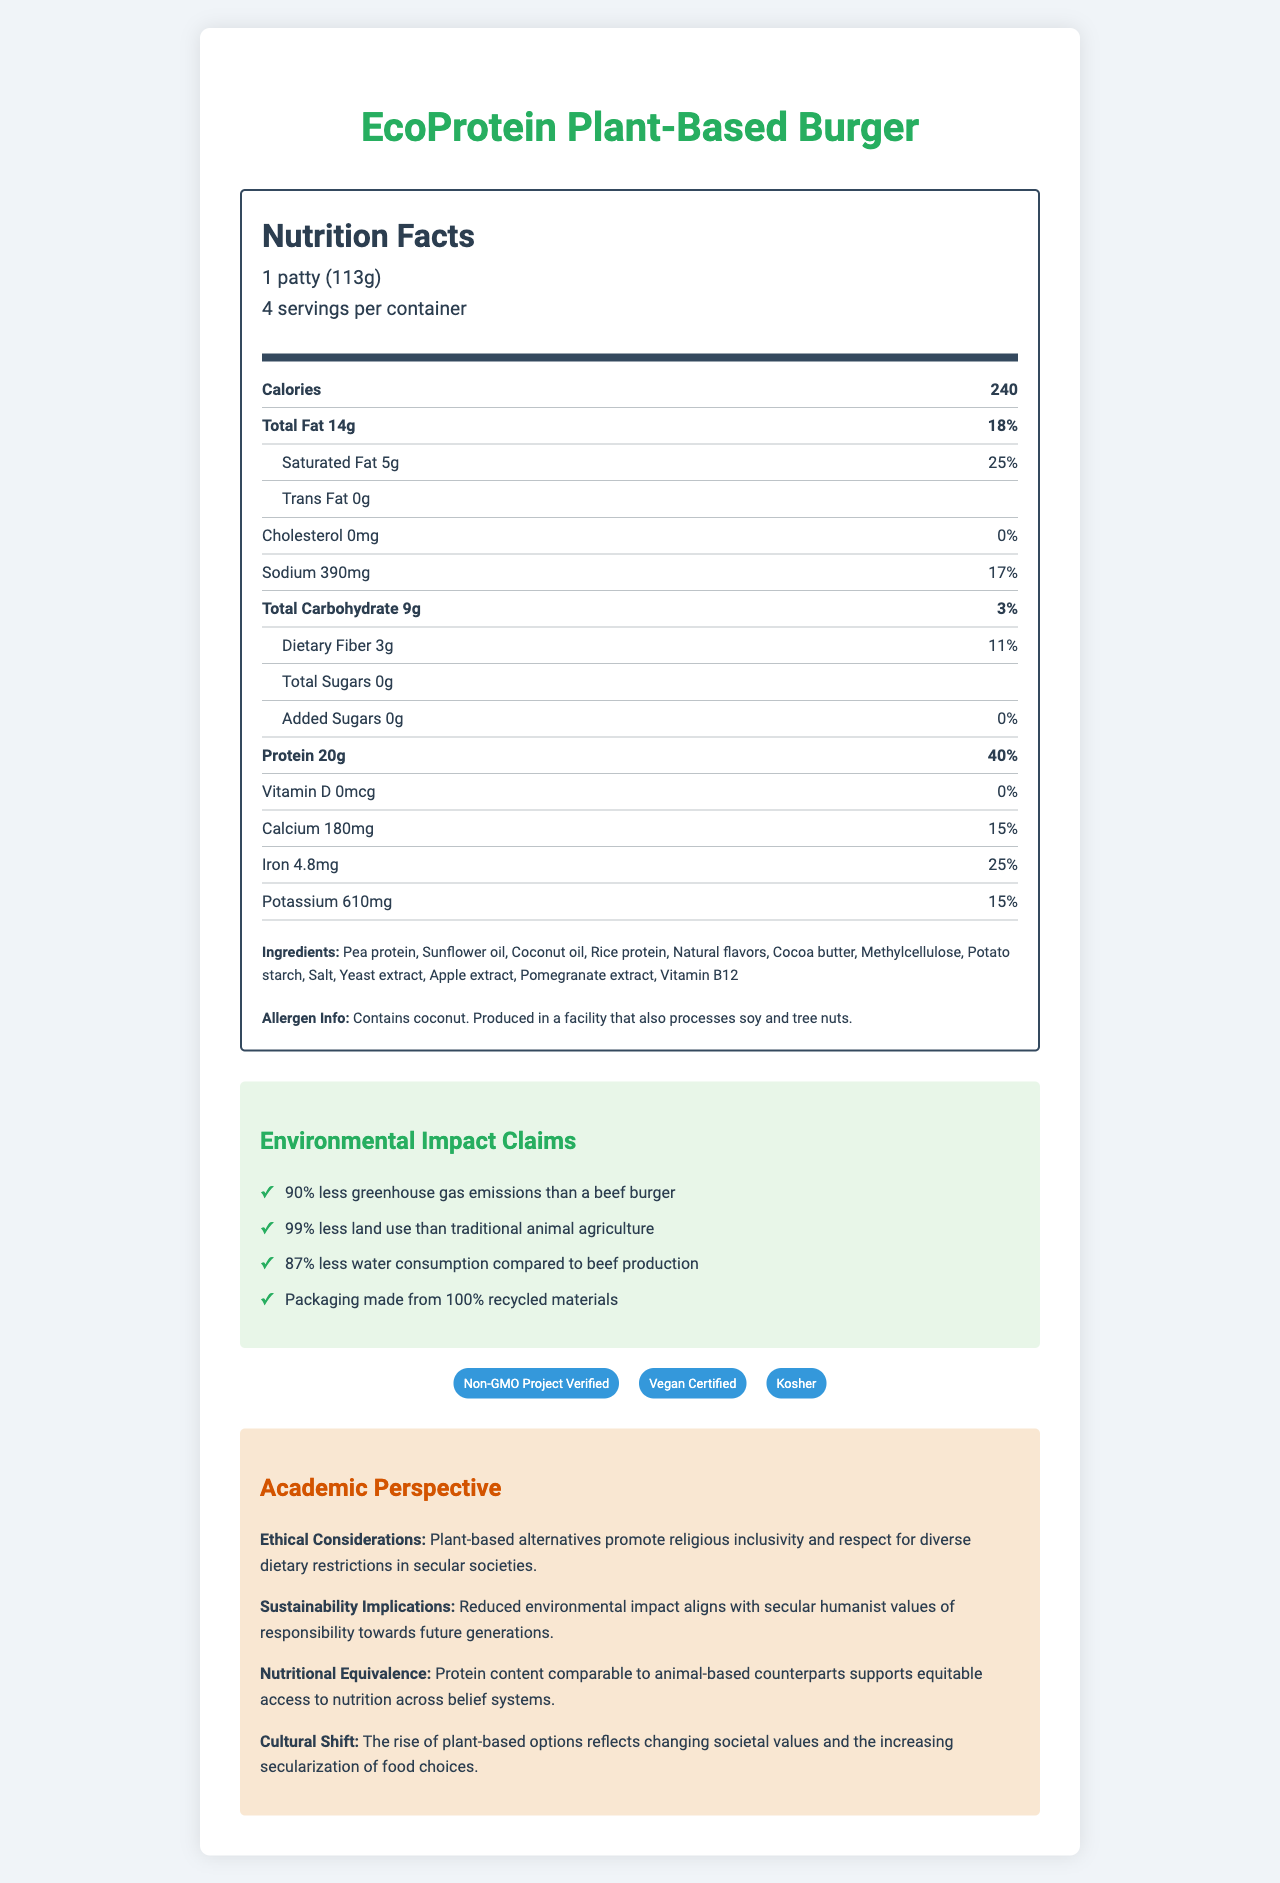how many servings are in one container? The document states there are 4 servings per container.
Answer: 4 What is the serving size of the EcoProtein Plant-Based Burger? The document lists the serving size as "1 patty (113g)."
Answer: 1 patty (113g) How many grams of protein are in one serving? The nutrition facts section states there are 20g of protein per serving.
Answer: 20g What percent of the daily value does the protein content represent? The document indicates that the protein content is 40% of the daily value.
Answer: 40% What ingredient is listed first in the ingredients section? The ingredients section lists "Pea protein" as the first ingredient.
Answer: Pea protein How much saturated fat does a serving contain? The document states that each serving contains 5g of saturated fat.
Answer: 5g what is the main source of protein in this product? A. Rice protein B. Pea protein C. Soy protein D. Wheat protein The ingredients section indicates that pea protein is the main source of protein listed first.
Answer: B. Pea protein how much water consumption is reduced by this product compared to beef production? A. 70% B. 78% C. 87% D. 90% The environmental impact claims list an "87% less water consumption compared to beef production" claim.
Answer: C. 87% Is this product certified vegan? The certifications section includes "Vegan Certified."
Answer: Yes Does this product contain any cholesterol? The nutrition facts indicate 0mg of cholesterol per serving, with a 0% daily value.
Answer: No Summarize the main features of the EcoProtein Plant-Based Burger. The document provides detailed nutritional information, environmental impact claims, certifications, and an academic perspective, emphasizing its protein content and sustainability.
Answer: The EcoProtein Plant-Based Burger is a plant-based meat alternative with 20g of protein per serving. It contains 240 calories per patty and includes ingredients such as pea protein and coconut oil. The product is vegan, Non-GMO Project Verified, and kosher. Outstandingly, it claims significant environmental benefits, including reduced greenhouse gas emissions, land use, and water consumption compared to beef. The package is made from 100% recycled materials. How many grams of sugars are added to the product? The nutrition facts section lists 0g of added sugars.
Answer: 0g What is the iron content per serving? The nutrition facts section states that each serving contains 4.8mg of iron.
Answer: 4.8mg Where is this product produced? The document does not provide information about where the product is produced.
Answer: Cannot be determined What certifications does the product have? The document lists these certifications in the certifications section.
Answer: Non-GMO Project Verified, Vegan Certified, Kosher What are the main environmental impact claims made by the product? The environmental impact claims section outlines these specific claims about the product's sustainability.
Answer: The product claims 90% less greenhouse gas emissions than a beef burger, 99% less land use than traditional animal agriculture, 87% less water consumption compared to beef production, and packaging made from 100% recycled materials. 